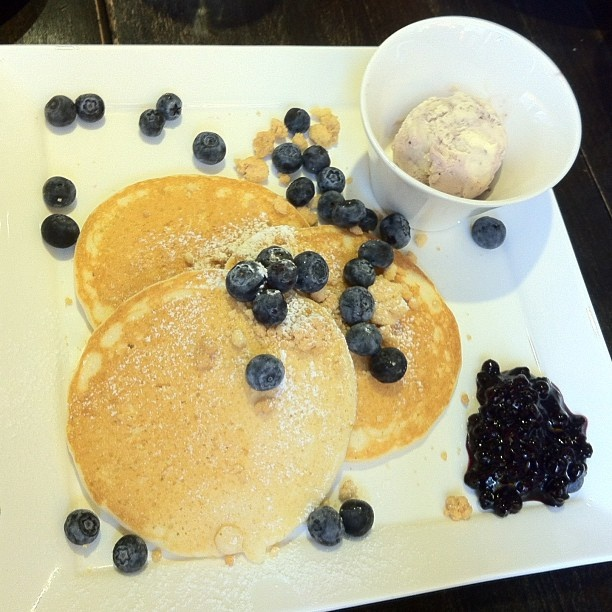Describe the objects in this image and their specific colors. I can see bowl in black, ivory, beige, darkgray, and tan tones and cup in black, ivory, beige, darkgray, and tan tones in this image. 